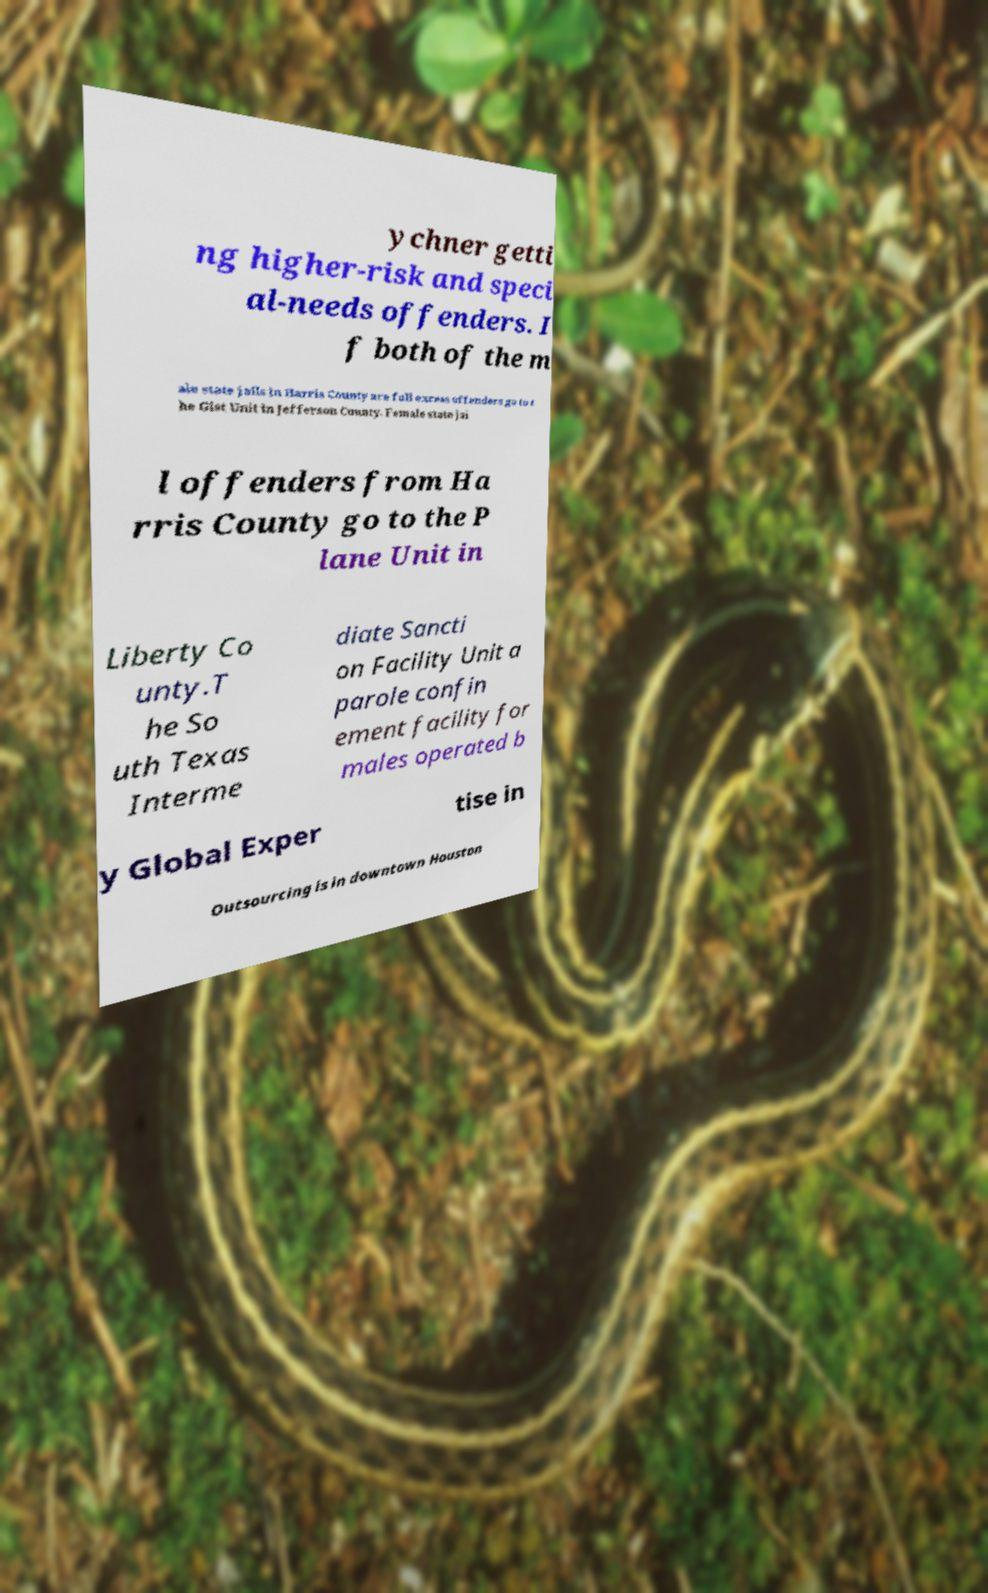Please identify and transcribe the text found in this image. ychner getti ng higher-risk and speci al-needs offenders. I f both of the m ale state jails in Harris County are full excess offenders go to t he Gist Unit in Jefferson County. Female state jai l offenders from Ha rris County go to the P lane Unit in Liberty Co unty.T he So uth Texas Interme diate Sancti on Facility Unit a parole confin ement facility for males operated b y Global Exper tise in Outsourcing is in downtown Houston 